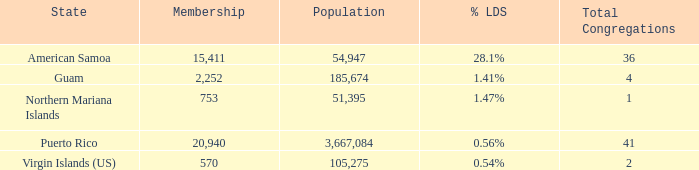54%? 105275.0. 